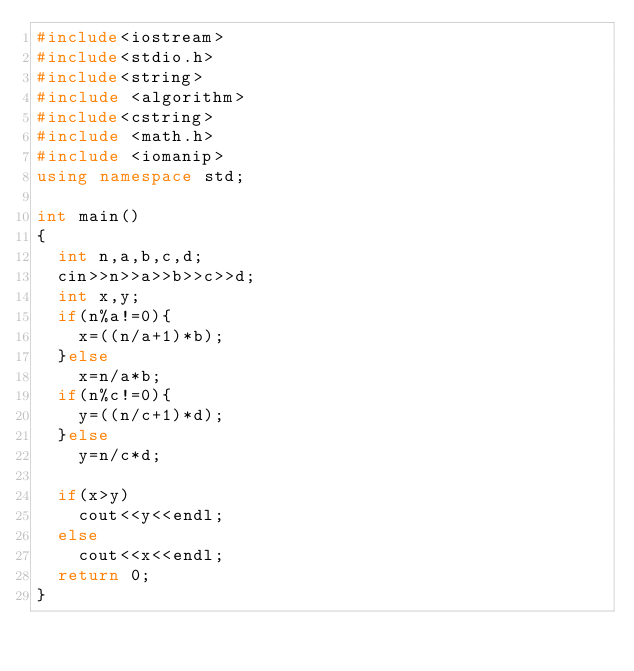Convert code to text. <code><loc_0><loc_0><loc_500><loc_500><_C++_>#include<iostream>
#include<stdio.h>
#include<string>
#include <algorithm>
#include<cstring>
#include <math.h>
#include <iomanip>
using namespace std;

int main()
{
  int n,a,b,c,d;
  cin>>n>>a>>b>>c>>d;
  int x,y;
  if(n%a!=0){
    x=((n/a+1)*b);
  }else
    x=n/a*b;
  if(n%c!=0){
    y=((n/c+1)*d);
  }else
    y=n/c*d;

  if(x>y)
    cout<<y<<endl;
  else
    cout<<x<<endl;
  return 0;
}

</code> 